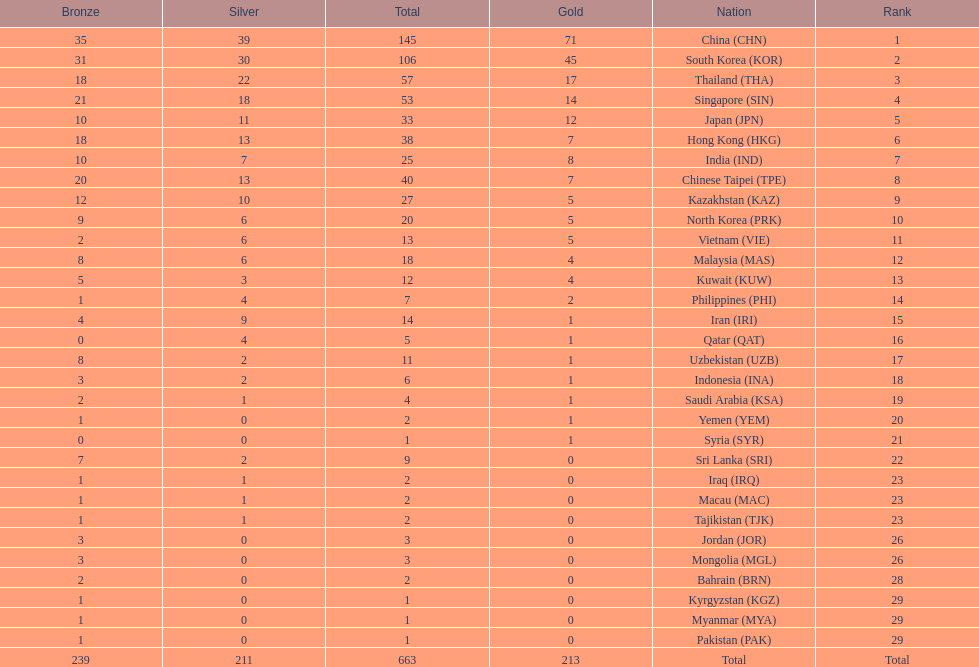Which countries have the same number of silver medals in the asian youth games as north korea? Vietnam (VIE), Malaysia (MAS). 